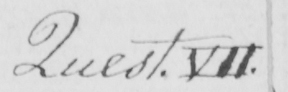What does this handwritten line say? Quest . VII . 